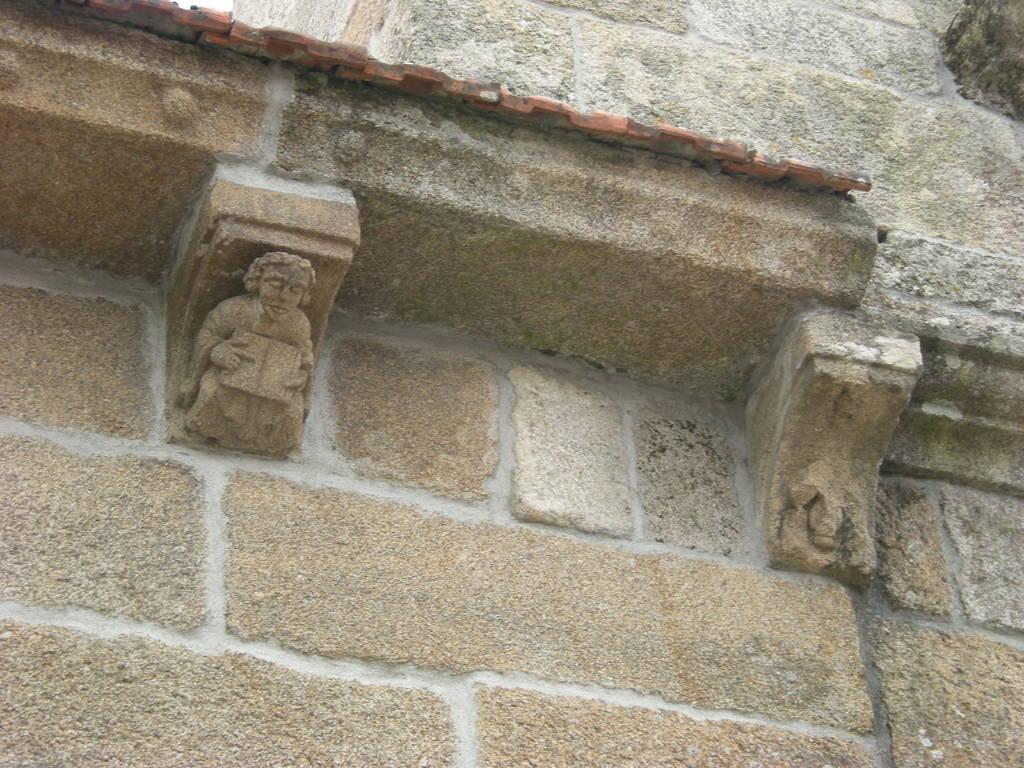How would you summarize this image in a sentence or two? In this image we can see a wall and some sculptures on it. 